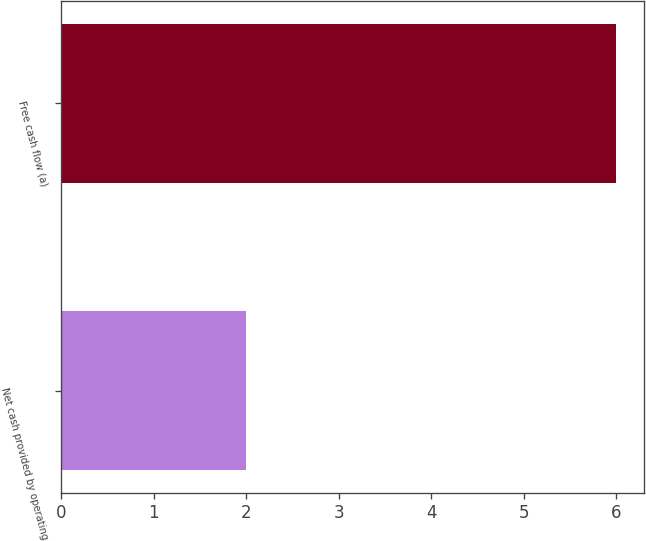Convert chart to OTSL. <chart><loc_0><loc_0><loc_500><loc_500><bar_chart><fcel>Net cash provided by operating<fcel>Free cash flow (a)<nl><fcel>2<fcel>6<nl></chart> 